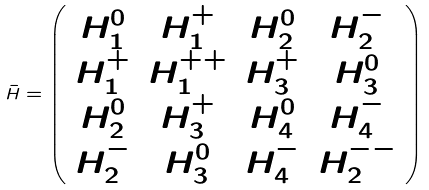<formula> <loc_0><loc_0><loc_500><loc_500>\bar { H } = \left ( \begin{array} { c c c c } H ^ { 0 } _ { 1 } & H ^ { + } _ { 1 } & H ^ { 0 } _ { 2 } & H ^ { - } _ { 2 } \\ H ^ { + } _ { 1 } & H ^ { + + } _ { 1 } & H ^ { + } _ { 3 } & H ^ { 0 } _ { 3 } \\ H ^ { 0 } _ { 2 } & H ^ { + } _ { 3 } & H ^ { 0 } _ { 4 } & H ^ { - } _ { 4 } \\ H ^ { - } _ { 2 } & H ^ { 0 } _ { 3 } & H ^ { - } _ { 4 } & H ^ { - - } _ { 2 } \end{array} \right )</formula> 